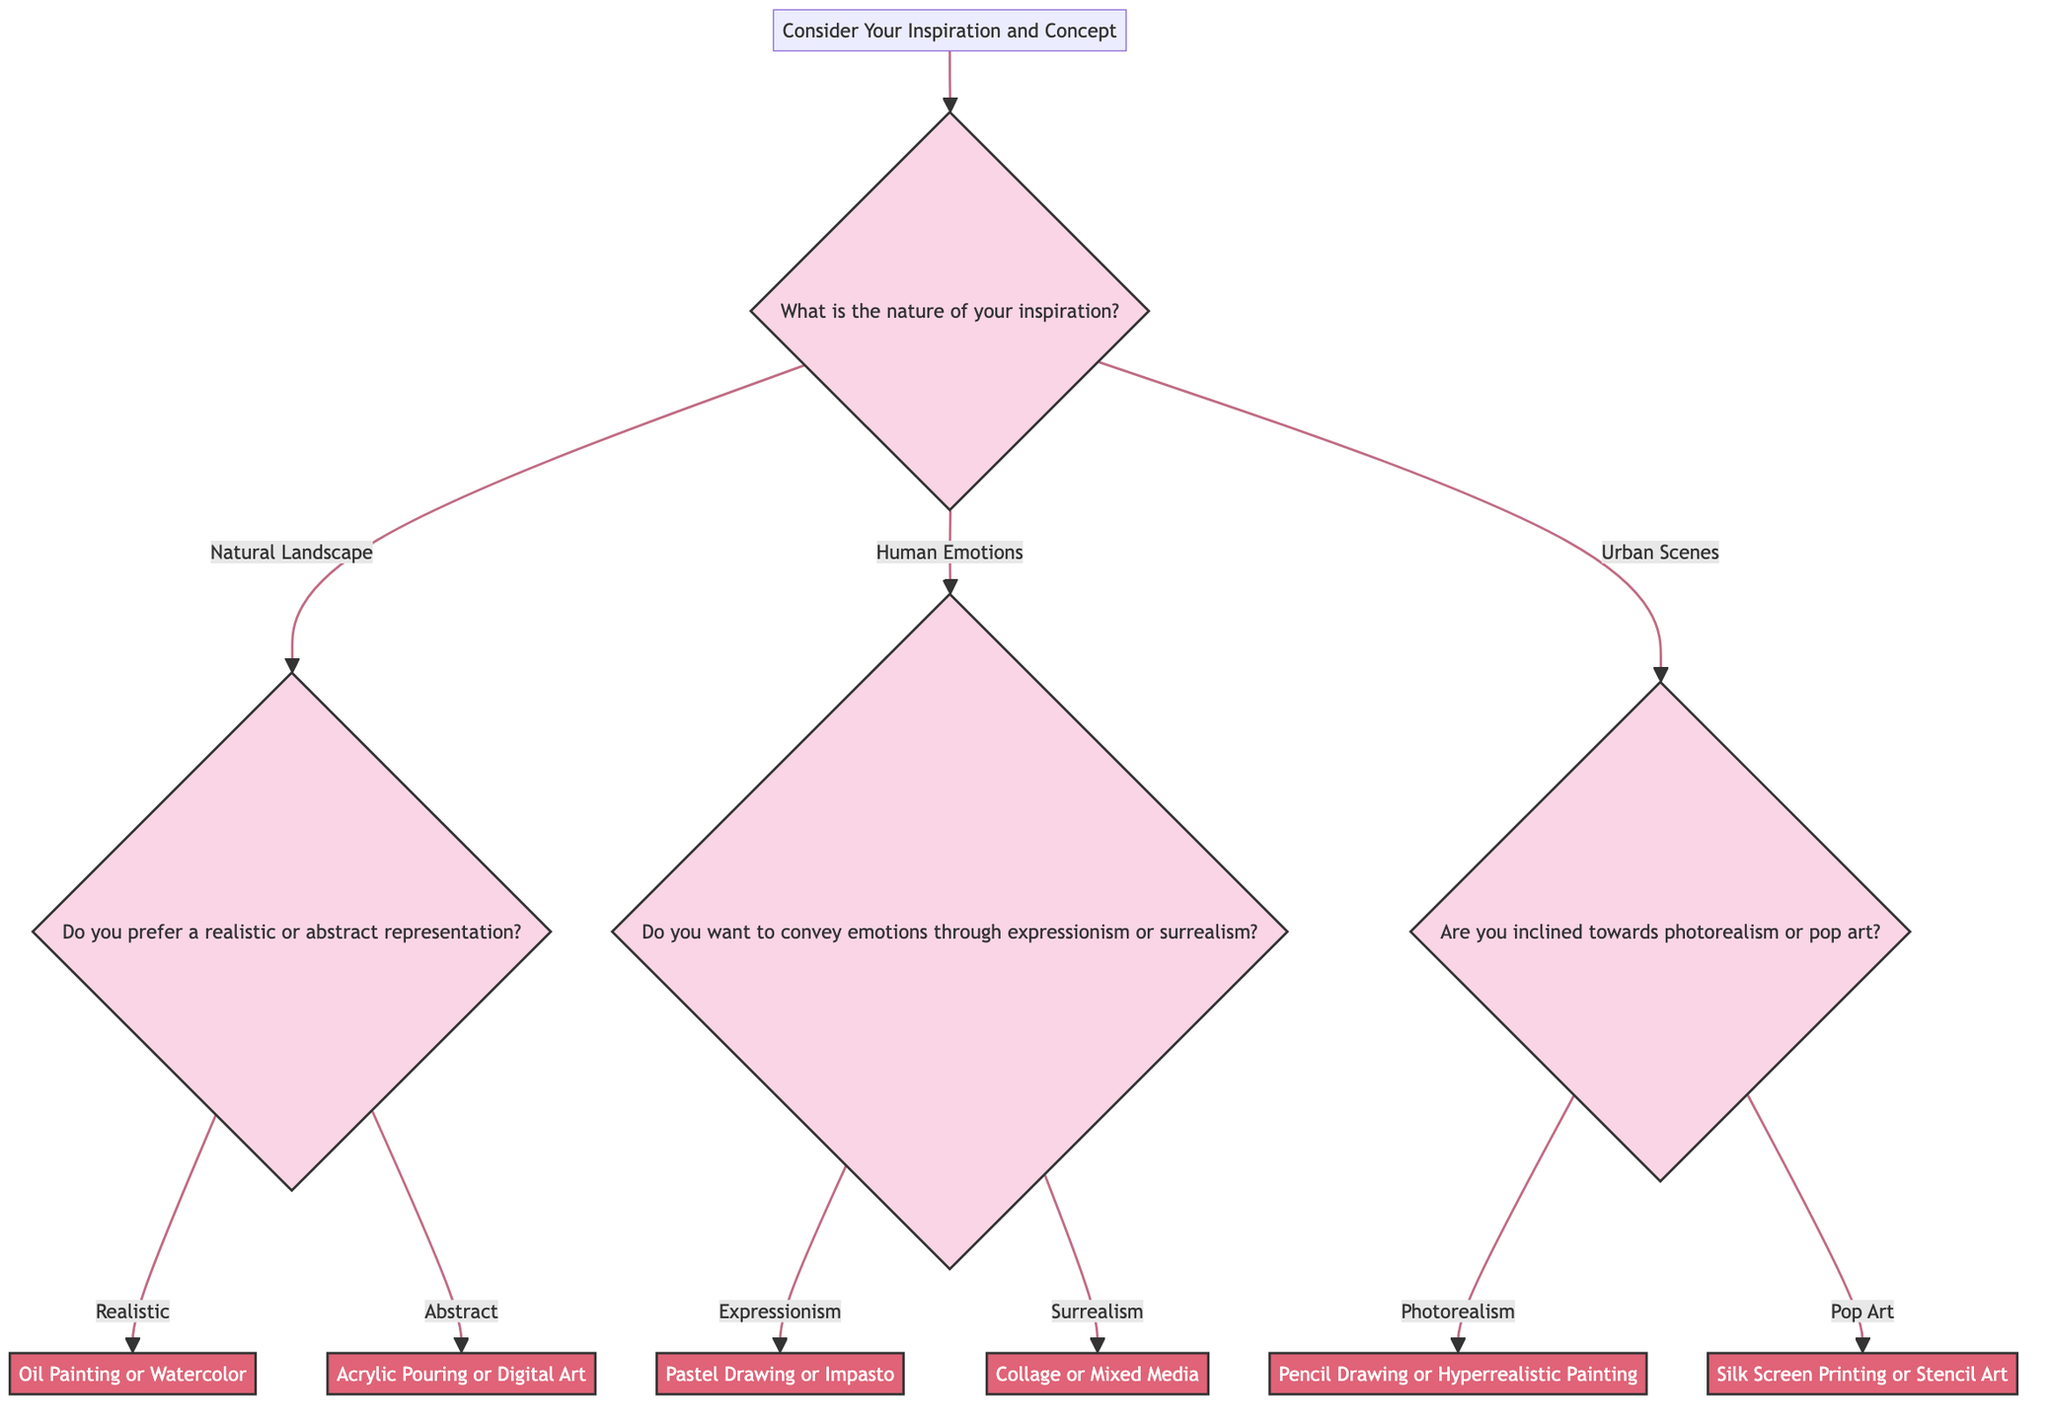What is the starting point of the decision tree? The starting point mentioned in the diagram is labeled as "Consider Your Inspiration and Concept," which serves as the entry point for exploring various artistic techniques based on inspiration.
Answer: Consider Your Inspiration and Concept How many main branches does the decision tree have after the starting point? After the starting point, the decision tree has three main branches connected to the first question about the nature of inspiration: Natural Landscape, Human Emotions, and Urban Scenes. This accounts for a total of three branches.
Answer: 3 What technique is recommended if one chooses "Realistic" representation? If the choice is "Realistic" representation after selecting "Natural Landscape," the recommendation given is "Oil Painting or Watercolor."
Answer: Oil Painting or Watercolor What options are presented for "Human Emotions"? The question regarding "Human Emotions" offers two options: "Expressionism" and "Surrealism," guiding the artist to further define their choice in conveying emotions.
Answer: Expressionism, Surrealism Which technique is suggested if one selects "Pop Art"? If "Pop Art" is chosen after the "Urban Scenes" question, the recommended technique is "Silk Screen Printing or Stencil Art," which focuses on bold and vibrant styles.
Answer: Silk Screen Printing or Stencil Art What follows the response about "Natural Landscape"? Following the response about "Natural Landscape," the next question posed is about preference between "realistic or abstract representation," guiding the artist toward specific technical directions.
Answer: Do you prefer a realistic or abstract representation? If an artist selects "Surrealism," what technique do they end up with? Selecting "Surrealism" leads to the recommendation of "Collage or Mixed Media," which aligns with the dreamlike quality inherent to surrealistic art.
Answer: Collage or Mixed Media What is the final node in the decision tree if an artist chooses "Abstract"? If the artist first selects "Natural Landscape" and then chooses "Abstract," they end up recommending "Acrylic Pouring or Digital Art," marking the final outcome of this path.
Answer: Acrylic Pouring or Digital Art Which question addresses the medium of "Pencil Drawing"? The medium "Pencil Drawing" is addressed under the question regarding "Urban Scenes," specifically when the answer "Photorealism" is selected, leading to this detailed technique recommendation.
Answer: Are you inclined towards photorealism or pop art? 